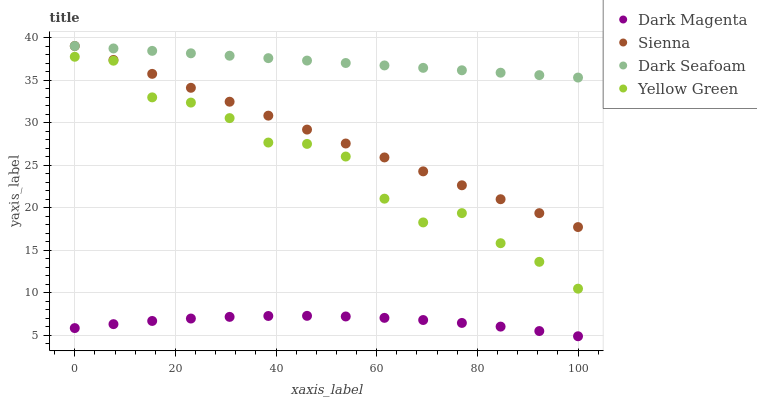Does Dark Magenta have the minimum area under the curve?
Answer yes or no. Yes. Does Dark Seafoam have the maximum area under the curve?
Answer yes or no. Yes. Does Dark Seafoam have the minimum area under the curve?
Answer yes or no. No. Does Dark Magenta have the maximum area under the curve?
Answer yes or no. No. Is Sienna the smoothest?
Answer yes or no. Yes. Is Yellow Green the roughest?
Answer yes or no. Yes. Is Dark Seafoam the smoothest?
Answer yes or no. No. Is Dark Seafoam the roughest?
Answer yes or no. No. Does Dark Magenta have the lowest value?
Answer yes or no. Yes. Does Dark Seafoam have the lowest value?
Answer yes or no. No. Does Dark Seafoam have the highest value?
Answer yes or no. Yes. Does Dark Magenta have the highest value?
Answer yes or no. No. Is Dark Magenta less than Sienna?
Answer yes or no. Yes. Is Dark Seafoam greater than Yellow Green?
Answer yes or no. Yes. Does Dark Seafoam intersect Sienna?
Answer yes or no. Yes. Is Dark Seafoam less than Sienna?
Answer yes or no. No. Is Dark Seafoam greater than Sienna?
Answer yes or no. No. Does Dark Magenta intersect Sienna?
Answer yes or no. No. 